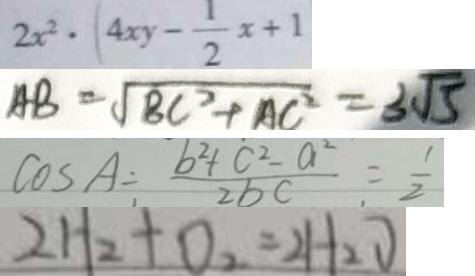Convert formula to latex. <formula><loc_0><loc_0><loc_500><loc_500>2 x ^ { 2 } \cdot ( 4 x y - \frac { 1 } { 2 } x + 1 
 A B = \sqrt { B C ^ { 2 } + A C ^ { 2 } } = 3 \sqrt { 5 } 
 \cos A \div \frac { b ^ { 2 } + c ^ { 2 } - a ^ { 2 } } { 2 b c } = \frac { 1 } { 2 } 
 2 H _ { 2 } + O _ { 2 } = 2 H _ { 2 } O</formula> 